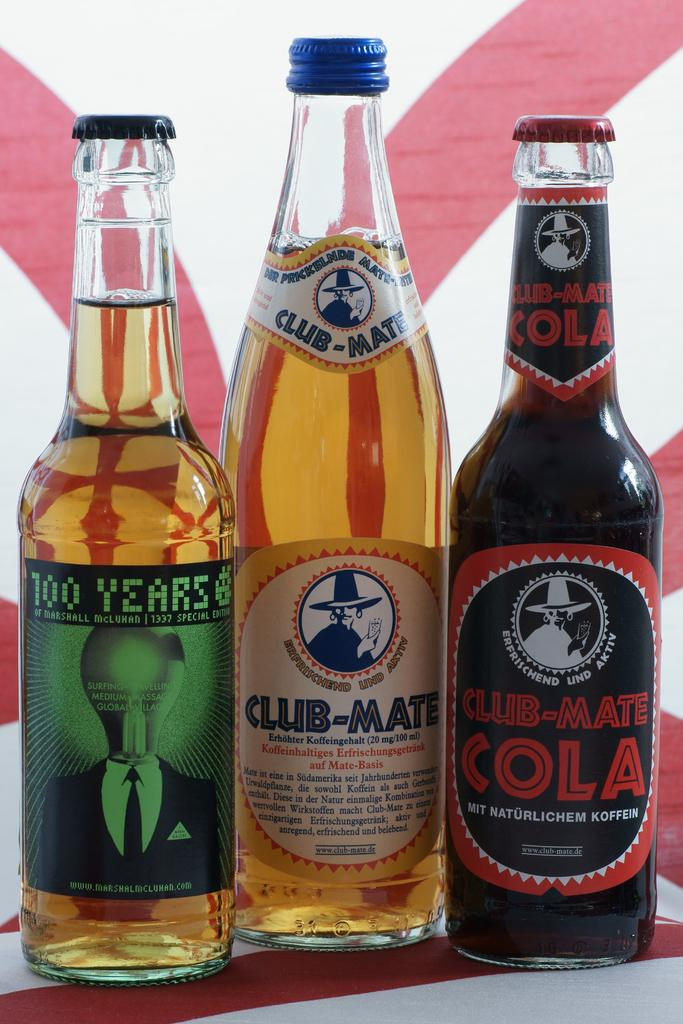<image>
Relay a brief, clear account of the picture shown. Three bottles of beverages with two of them having the words "club-mate" on it. 